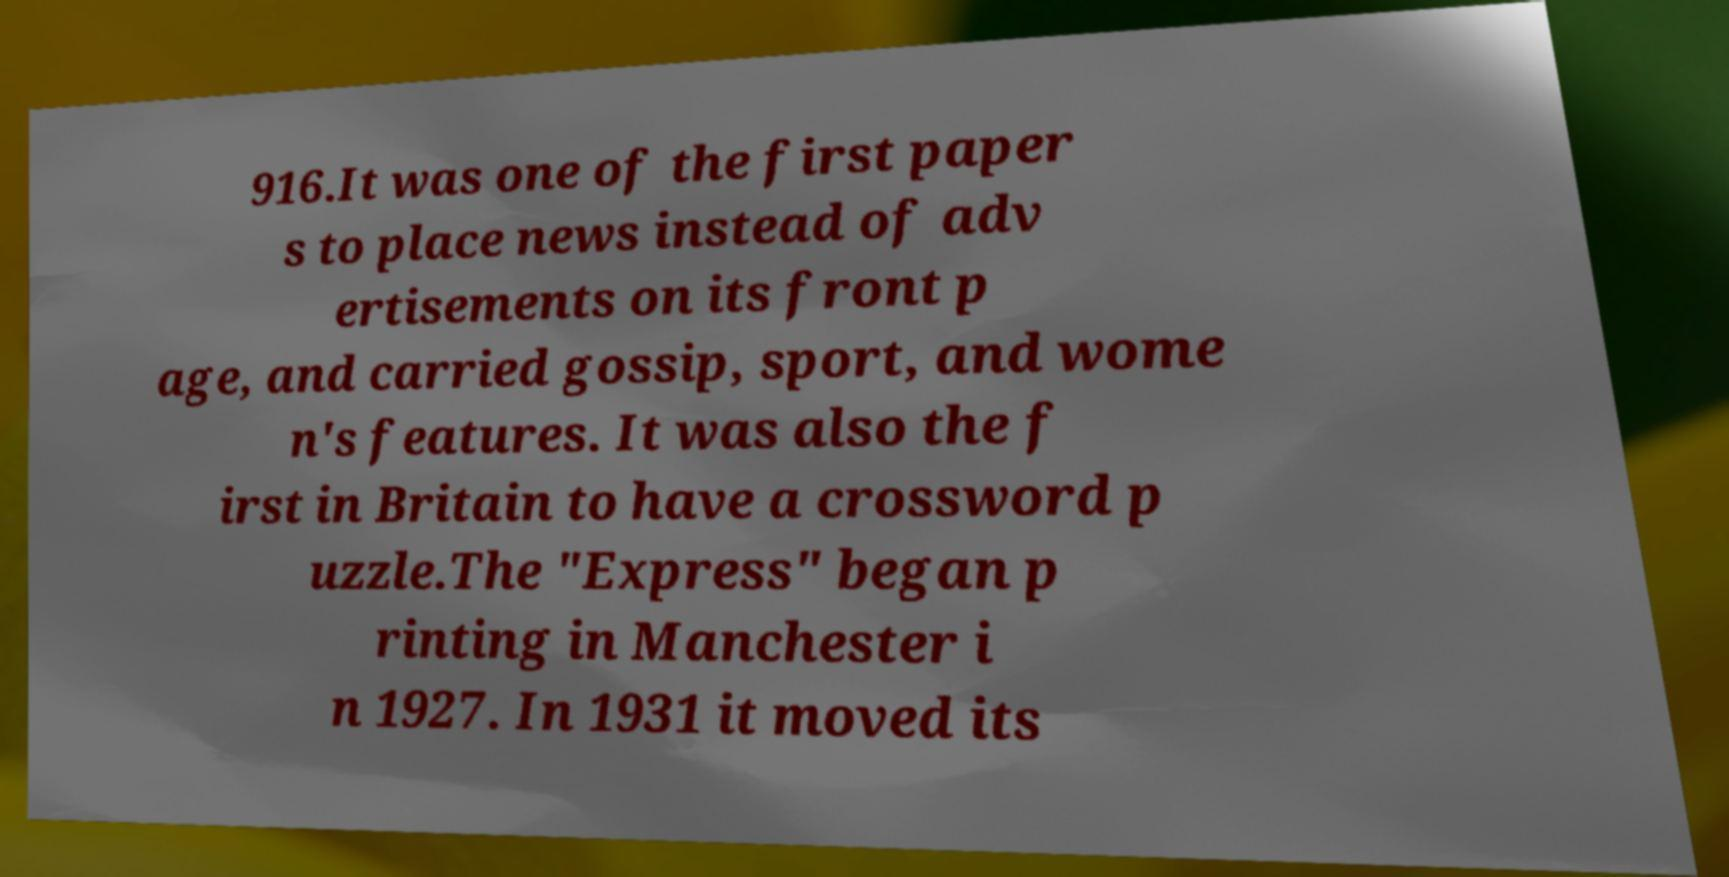Can you read and provide the text displayed in the image?This photo seems to have some interesting text. Can you extract and type it out for me? 916.It was one of the first paper s to place news instead of adv ertisements on its front p age, and carried gossip, sport, and wome n's features. It was also the f irst in Britain to have a crossword p uzzle.The "Express" began p rinting in Manchester i n 1927. In 1931 it moved its 